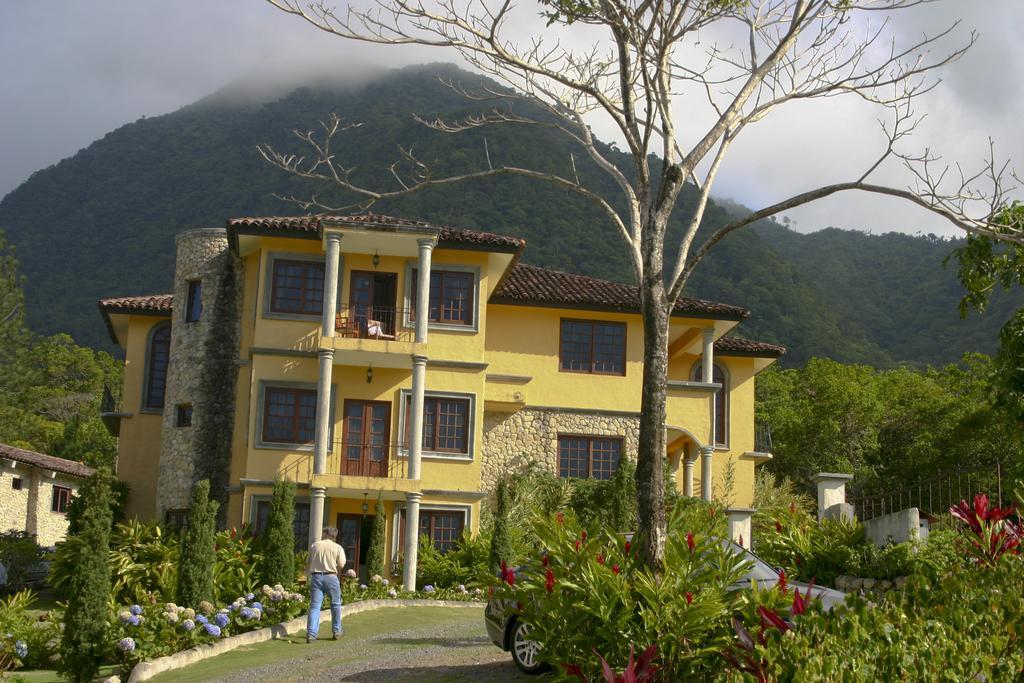Describe this image in one or two sentences. In the picture there is a building and around the building there are many plants and trees and there is a car beside a tree and there is a man behind the car, in the background there are mountains. 